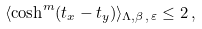<formula> <loc_0><loc_0><loc_500><loc_500>\langle \cosh ^ { m } ( t _ { x } - t _ { y } ) \rangle _ { \Lambda , \beta , \, \varepsilon } \leq 2 \, ,</formula> 